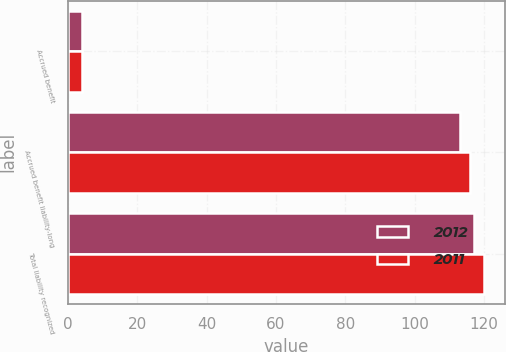<chart> <loc_0><loc_0><loc_500><loc_500><stacked_bar_chart><ecel><fcel>Accrued benefit<fcel>Accrued benefit liability-long<fcel>Total liability recognized<nl><fcel>2012<fcel>4<fcel>113<fcel>117<nl><fcel>2011<fcel>4<fcel>116<fcel>120<nl></chart> 